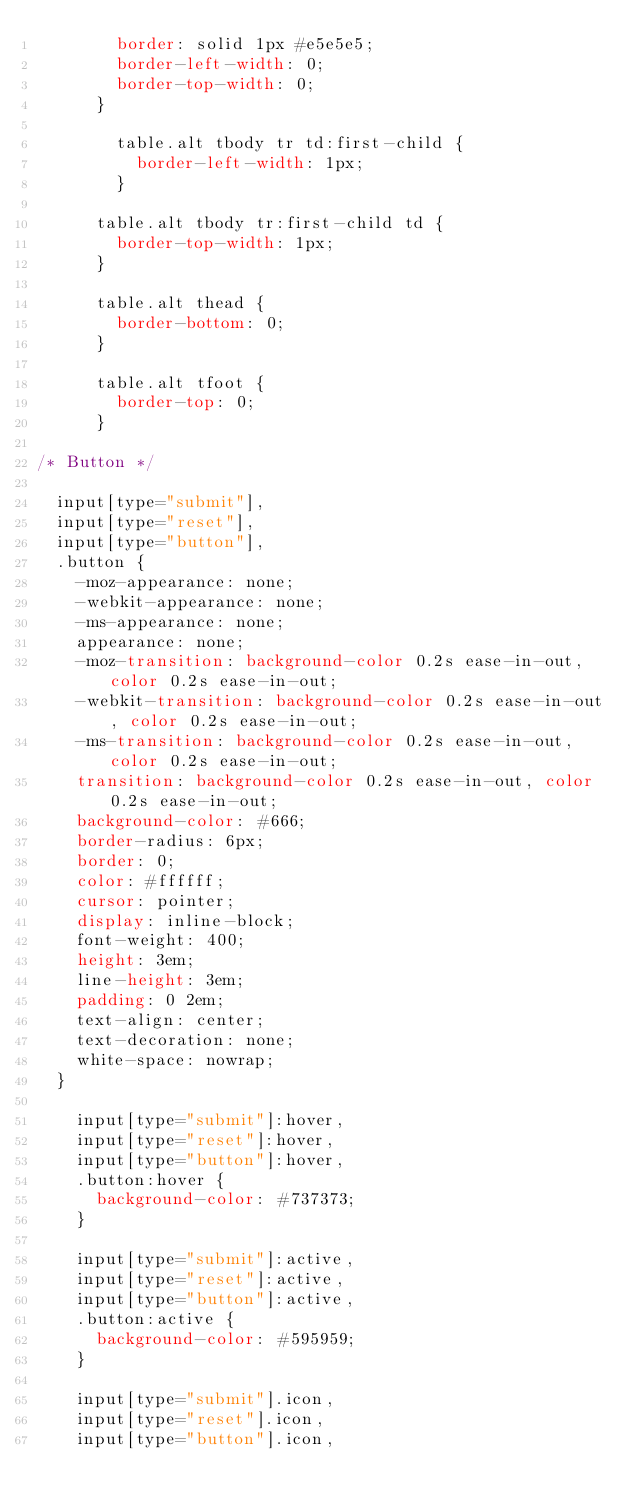<code> <loc_0><loc_0><loc_500><loc_500><_CSS_>				border: solid 1px #e5e5e5;
				border-left-width: 0;
				border-top-width: 0;
			}

				table.alt tbody tr td:first-child {
					border-left-width: 1px;
				}

			table.alt tbody tr:first-child td {
				border-top-width: 1px;
			}

			table.alt thead {
				border-bottom: 0;
			}

			table.alt tfoot {
				border-top: 0;
			}

/* Button */

	input[type="submit"],
	input[type="reset"],
	input[type="button"],
	.button {
		-moz-appearance: none;
		-webkit-appearance: none;
		-ms-appearance: none;
		appearance: none;
		-moz-transition: background-color 0.2s ease-in-out, color 0.2s ease-in-out;
		-webkit-transition: background-color 0.2s ease-in-out, color 0.2s ease-in-out;
		-ms-transition: background-color 0.2s ease-in-out, color 0.2s ease-in-out;
		transition: background-color 0.2s ease-in-out, color 0.2s ease-in-out;
		background-color: #666;
		border-radius: 6px;
		border: 0;
		color: #ffffff;
		cursor: pointer;
		display: inline-block;
		font-weight: 400;
		height: 3em;
		line-height: 3em;
		padding: 0 2em;
		text-align: center;
		text-decoration: none;
		white-space: nowrap;
	}

		input[type="submit"]:hover,
		input[type="reset"]:hover,
		input[type="button"]:hover,
		.button:hover {
			background-color: #737373;
		}

		input[type="submit"]:active,
		input[type="reset"]:active,
		input[type="button"]:active,
		.button:active {
			background-color: #595959;
		}

		input[type="submit"].icon,
		input[type="reset"].icon,
		input[type="button"].icon,</code> 